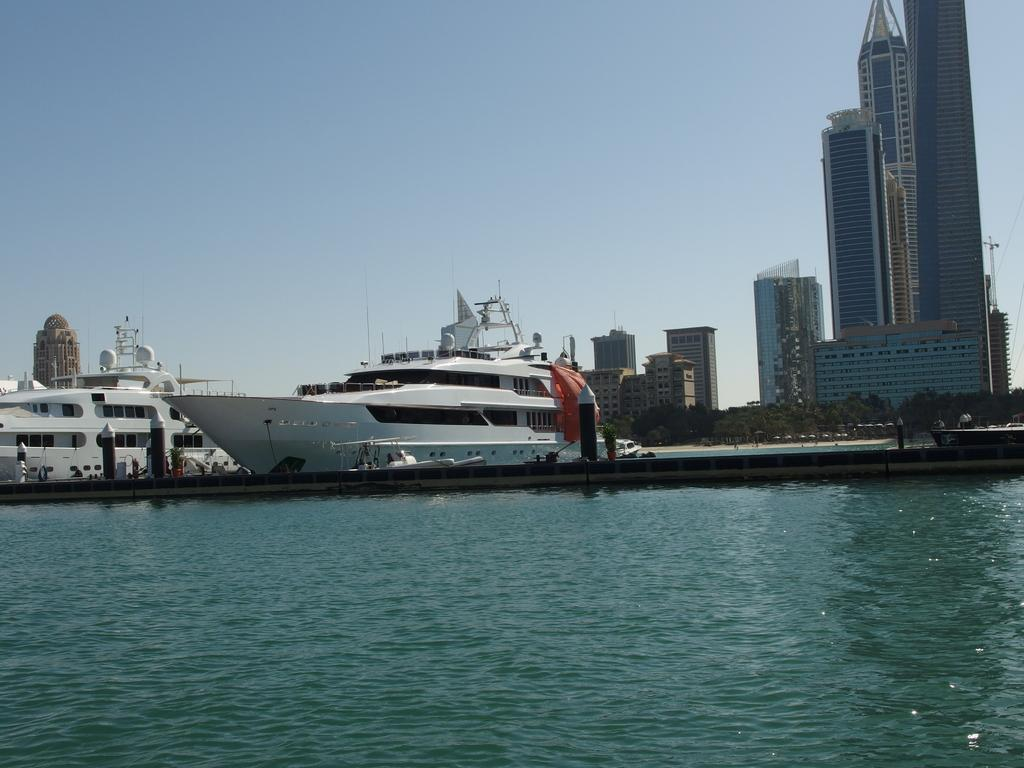What is present at the bottom of the image? There is water in the bottom of the image. What can be seen in the middle of the image? There are boats in the middle of the image. What structures are located on the right side of the image? There are buildings and trees on the right side of the image. What is visible at the top of the image? The sky is visible at the top of the image. How much salt is present in the water in the image? There is no information about the salt content in the water in the image. What hobbies do the buildings on the right side of the image have? Buildings do not have hobbies; they are inanimate structures. 